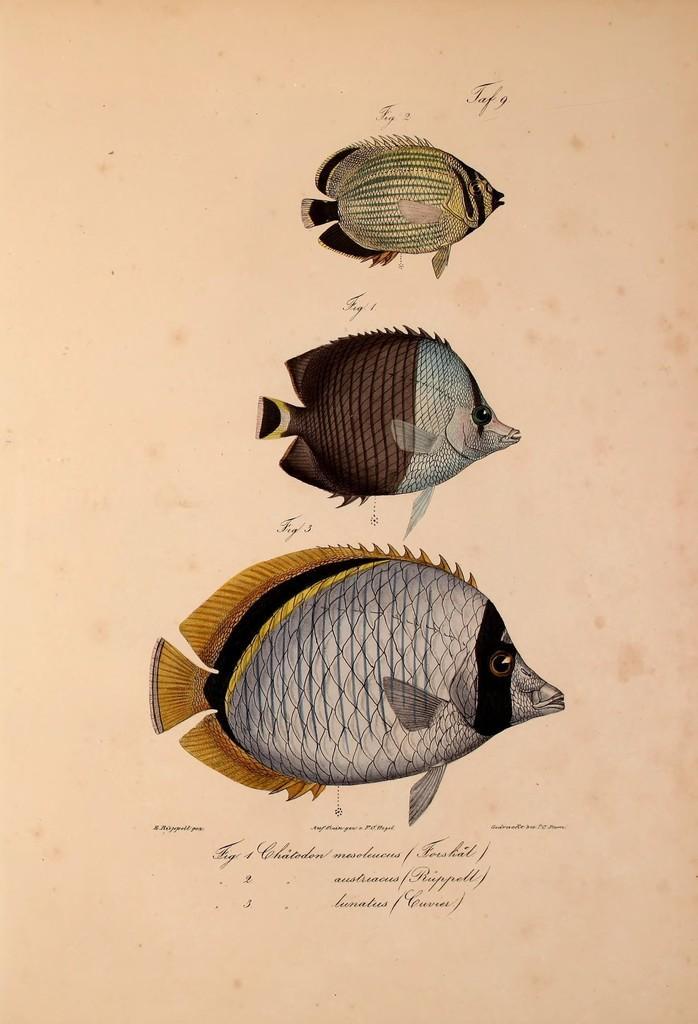Please provide a concise description of this image. Here we can see three different sized fishes drawn on a paper and we can also see text written on the paper. 